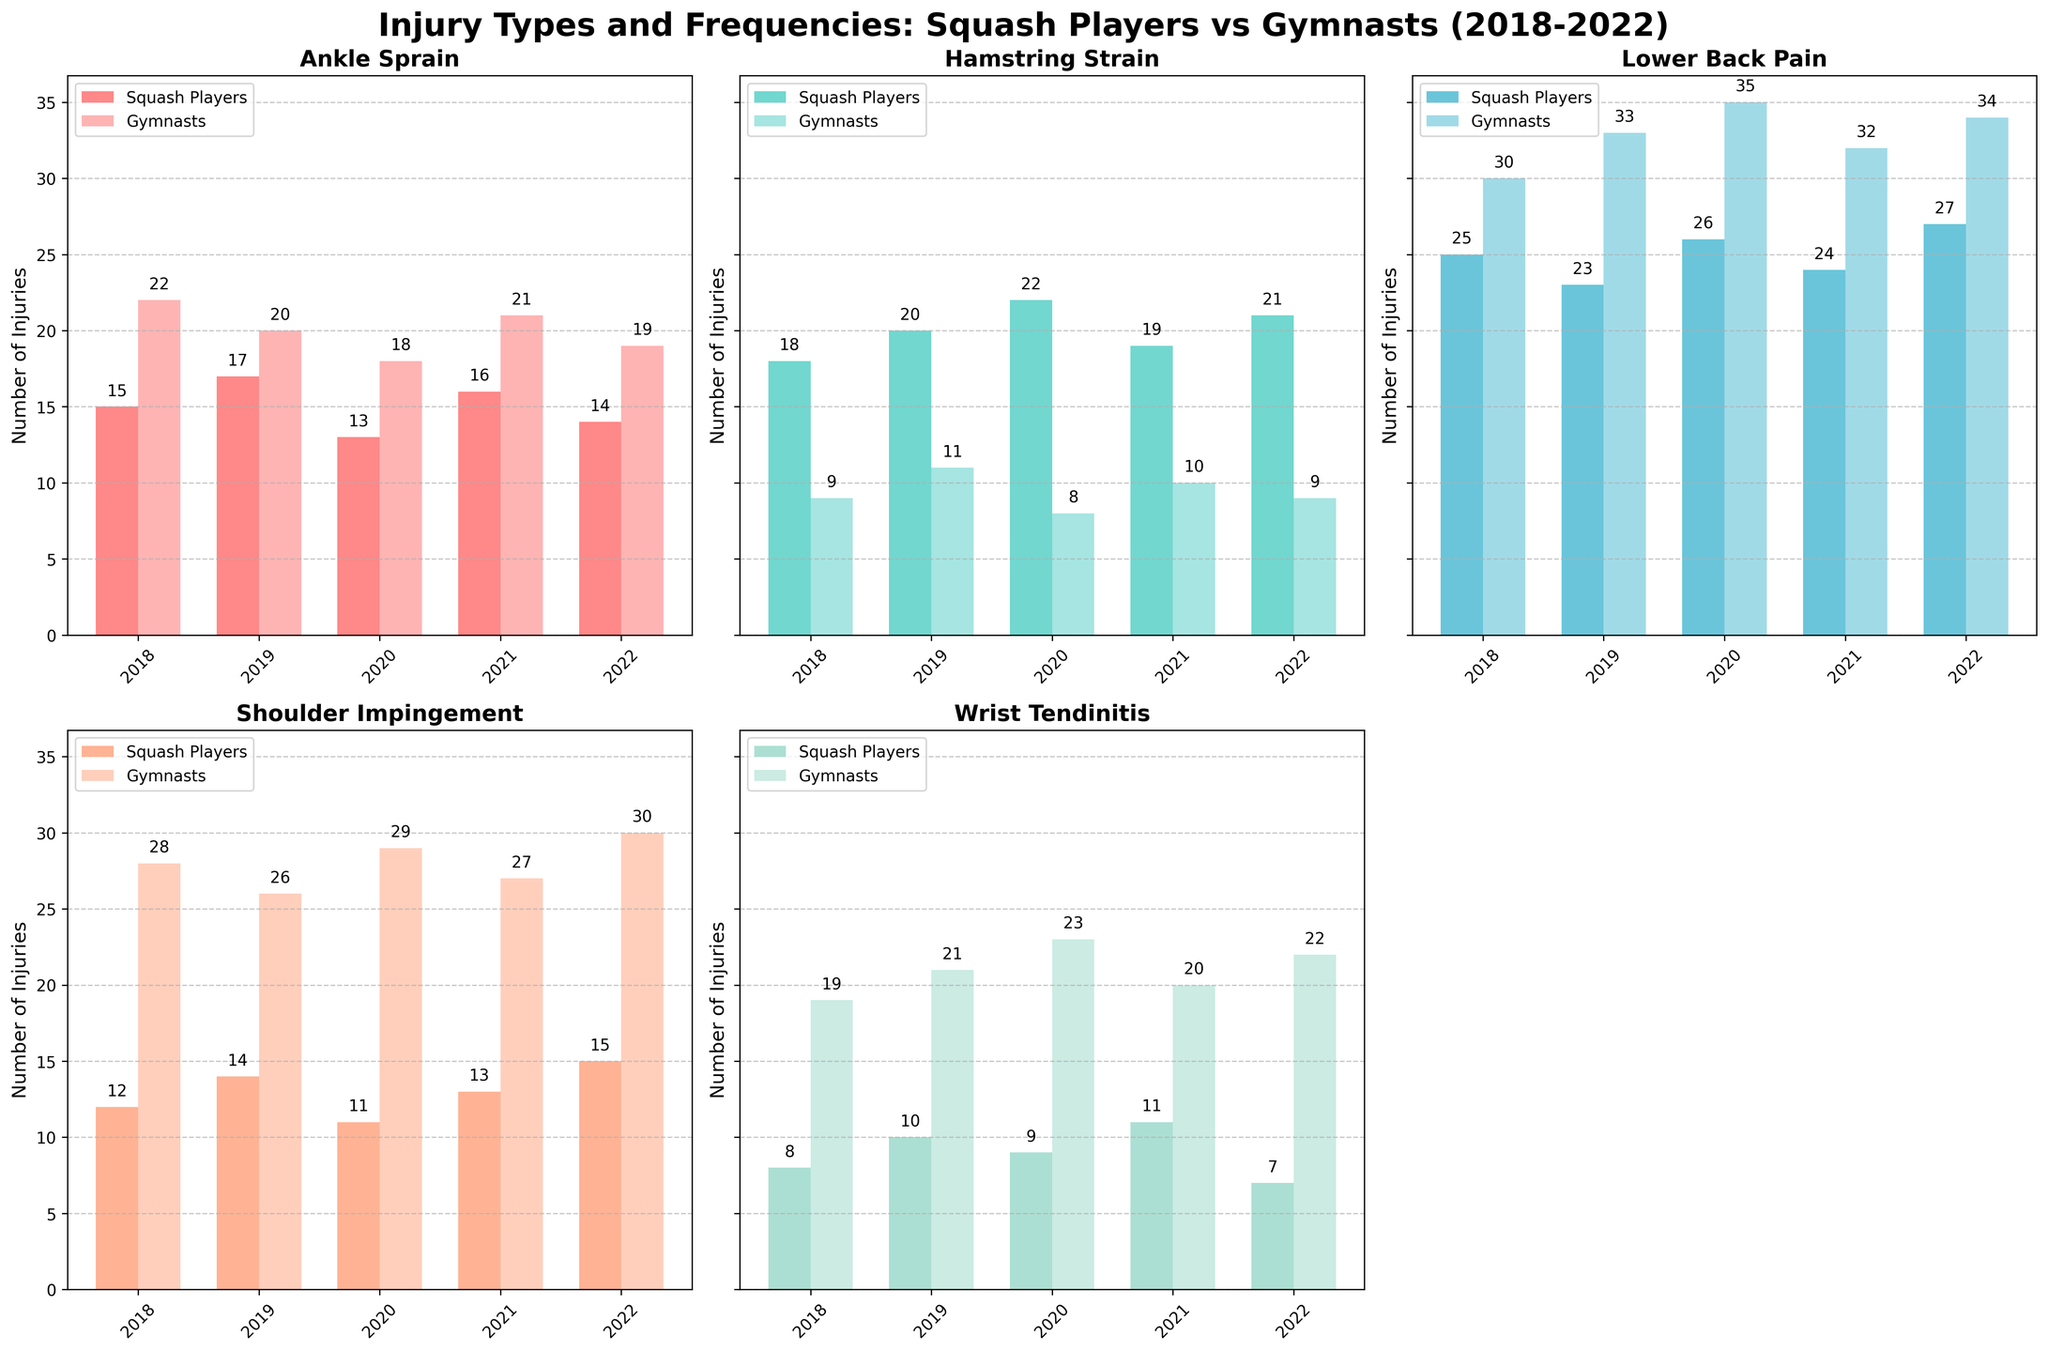What is the total number of ankle sprain injuries for squash players over the 5-year period? Sum up the ankle sprain injuries for each year: 15 (2018) + 17 (2019) + 13 (2020) + 16 (2021) + 14 (2022) = 75
Answer: 75 Which injury type has the highest frequency among gymnasts in 2020? Look at the bars for gymnasts in 2020 and identify the tallest one. Lower back pain has 35 injuries, which is the highest.
Answer: Lower back pain How does the frequency of wrist tendinitis in squash players change from 2018 to 2022? Compare the numbers for wrist tendinitis in squash players from 2018 (8) to 2022 (7). It decreased slightly.
Answer: Decreased What is the average number of lower back pain injuries for gymnasts over the 5-year period? Add the lower back pain injuries for each year for gymnasts: 30 (2018) + 33 (2019) + 35 (2020) + 32 (2021) + 34 (2022). The total is 164. The average is 164 / 5 = 32.8.
Answer: 32.8 Which injury type has consistently more injuries among gymnasts compared to squash players over the years? Compare the bars for each injury type. Shoulder impingement shows consistently more injuries among gymnasts each year.
Answer: Shoulder impingement In which year do squash players have the highest number of hamstring strains? Identify the tallest bar for hamstring strains among squash players. 2020 has the highest number with 22.
Answer: 2020 How many more shoulder impingement injuries did gymnasts have compared to squash players in 2021? Subtract the number of shoulder impingement injuries for squash players from the number for gymnasts in 2021: 27 - 13 = 14.
Answer: 14 What is the total number of injuries for gymnasts in 2022? Sum the injuries for all types in 2022 for gymnasts: 19 (Ankle Sprain) + 9 (Hamstring Strain) + 34 (Lower Back Pain) + 30 (Shoulder Impingement) + 22 (Wrist Tendinitis) = 114
Answer: 114 Which injury type and year combination represents the highest number of injuries for squash players? Identify the tallest bar among all injury types for squash players. Lower back pain in 2022 with 27 injuries is the highest.
Answer: Lower back pain in 2022 What can be said about the trend of lower back pain among squash players over the 5-year period? Observing the bars for lower back pain among squash players from 2018 to 2022: 25 (2018), 23 (2019), 26 (2020), 24 (2021), 27 (2022), the trend shows a slight increase.
Answer: Slight increase 